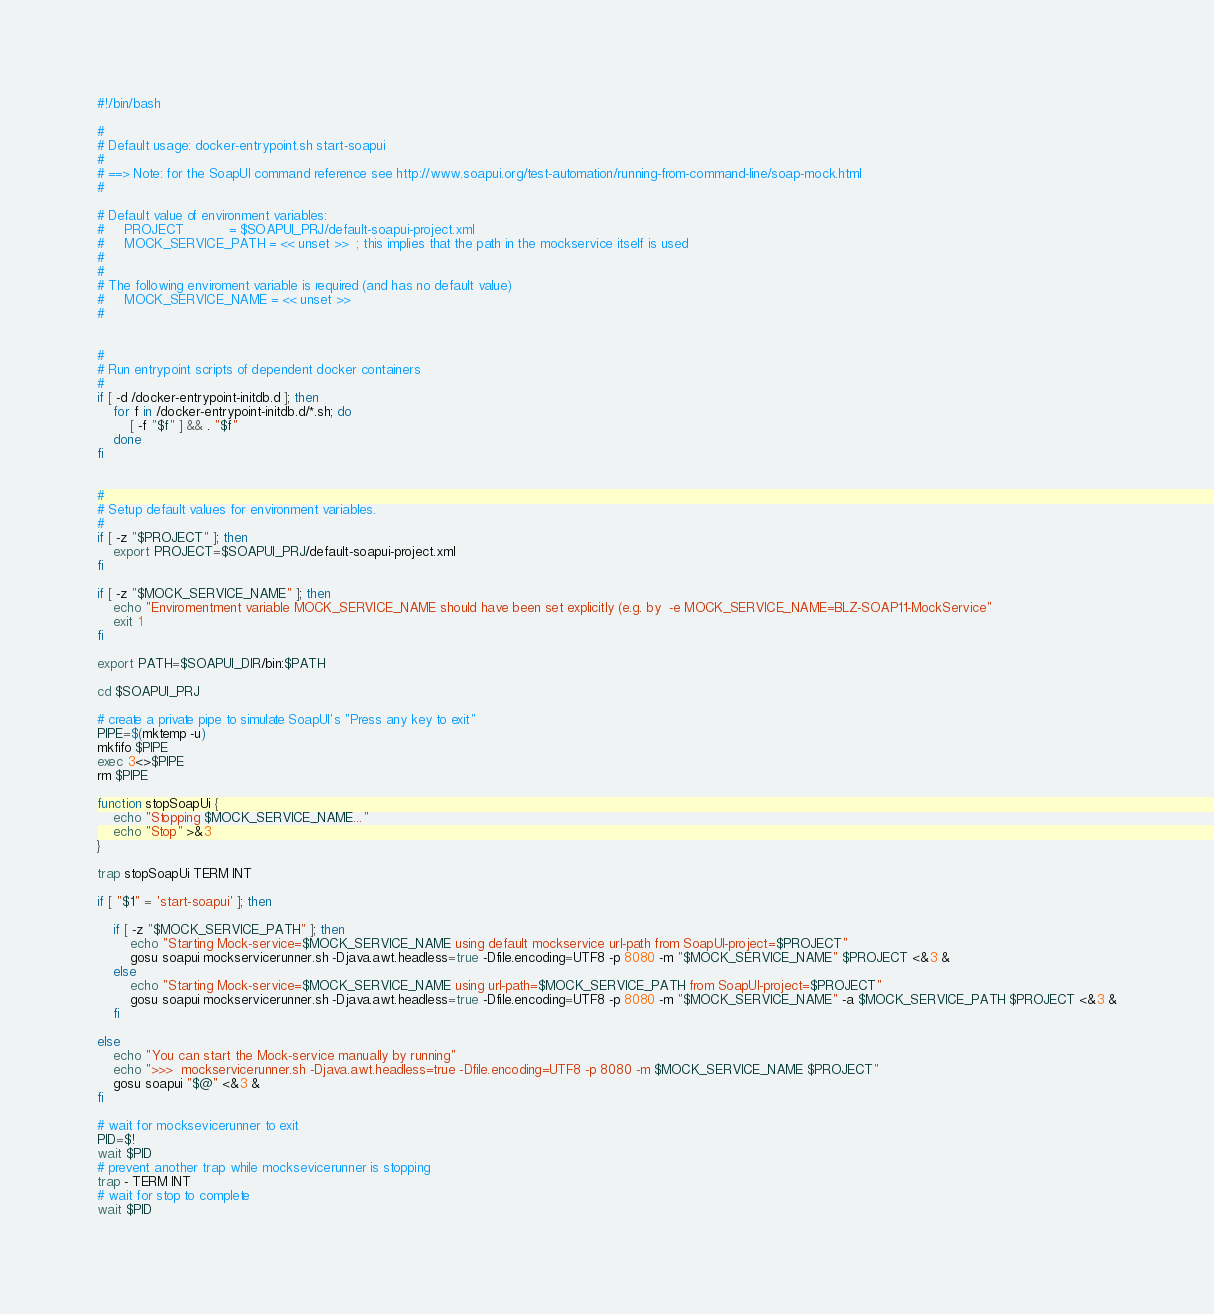Convert code to text. <code><loc_0><loc_0><loc_500><loc_500><_Bash_>#!/bin/bash

#
# Default usage: docker-entrypoint.sh start-soapui
#
# ==> Note: for the SoapUI command reference see http://www.soapui.org/test-automation/running-from-command-line/soap-mock.html
#

# Default value of environment variables:
#     PROJECT           = $SOAPUI_PRJ/default-soapui-project.xml
#     MOCK_SERVICE_PATH = << unset >>  ; this implies that the path in the mockservice itself is used
#
#
# The following enviroment variable is required (and has no default value)
#     MOCK_SERVICE_NAME = << unset >>
#


#
# Run entrypoint scripts of dependent docker containers
#
if [ -d /docker-entrypoint-initdb.d ]; then
    for f in /docker-entrypoint-initdb.d/*.sh; do
        [ -f "$f" ] && . "$f"
    done
fi


#
# Setup default values for environment variables.
#
if [ -z "$PROJECT" ]; then
    export PROJECT=$SOAPUI_PRJ/default-soapui-project.xml
fi

if [ -z "$MOCK_SERVICE_NAME" ]; then
    echo "Enviromentment variable MOCK_SERVICE_NAME should have been set explicitly (e.g. by  -e MOCK_SERVICE_NAME=BLZ-SOAP11-MockService"
    exit 1
fi

export PATH=$SOAPUI_DIR/bin:$PATH

cd $SOAPUI_PRJ

# create a private pipe to simulate SoapUI's "Press any key to exit"
PIPE=$(mktemp -u)
mkfifo $PIPE
exec 3<>$PIPE
rm $PIPE

function stopSoapUi {
    echo "Stopping $MOCK_SERVICE_NAME..."
    echo "Stop" >&3
}

trap stopSoapUi TERM INT

if [ "$1" = 'start-soapui' ]; then

    if [ -z "$MOCK_SERVICE_PATH" ]; then
        echo "Starting Mock-service=$MOCK_SERVICE_NAME using default mockservice url-path from SoapUI-project=$PROJECT"
        gosu soapui mockservicerunner.sh -Djava.awt.headless=true -Dfile.encoding=UTF8 -p 8080 -m "$MOCK_SERVICE_NAME" $PROJECT <&3 &
    else
        echo "Starting Mock-service=$MOCK_SERVICE_NAME using url-path=$MOCK_SERVICE_PATH from SoapUI-project=$PROJECT"
        gosu soapui mockservicerunner.sh -Djava.awt.headless=true -Dfile.encoding=UTF8 -p 8080 -m "$MOCK_SERVICE_NAME" -a $MOCK_SERVICE_PATH $PROJECT <&3 &
    fi

else
    echo "You can start the Mock-service manually by running"
    echo ">>>  mockservicerunner.sh -Djava.awt.headless=true -Dfile.encoding=UTF8 -p 8080 -m $MOCK_SERVICE_NAME $PROJECT"
    gosu soapui "$@" <&3 &
fi

# wait for mocksevicerunner to exit
PID=$!
wait $PID
# prevent another trap while mocksevicerunner is stopping
trap - TERM INT
# wait for stop to complete
wait $PID

</code> 